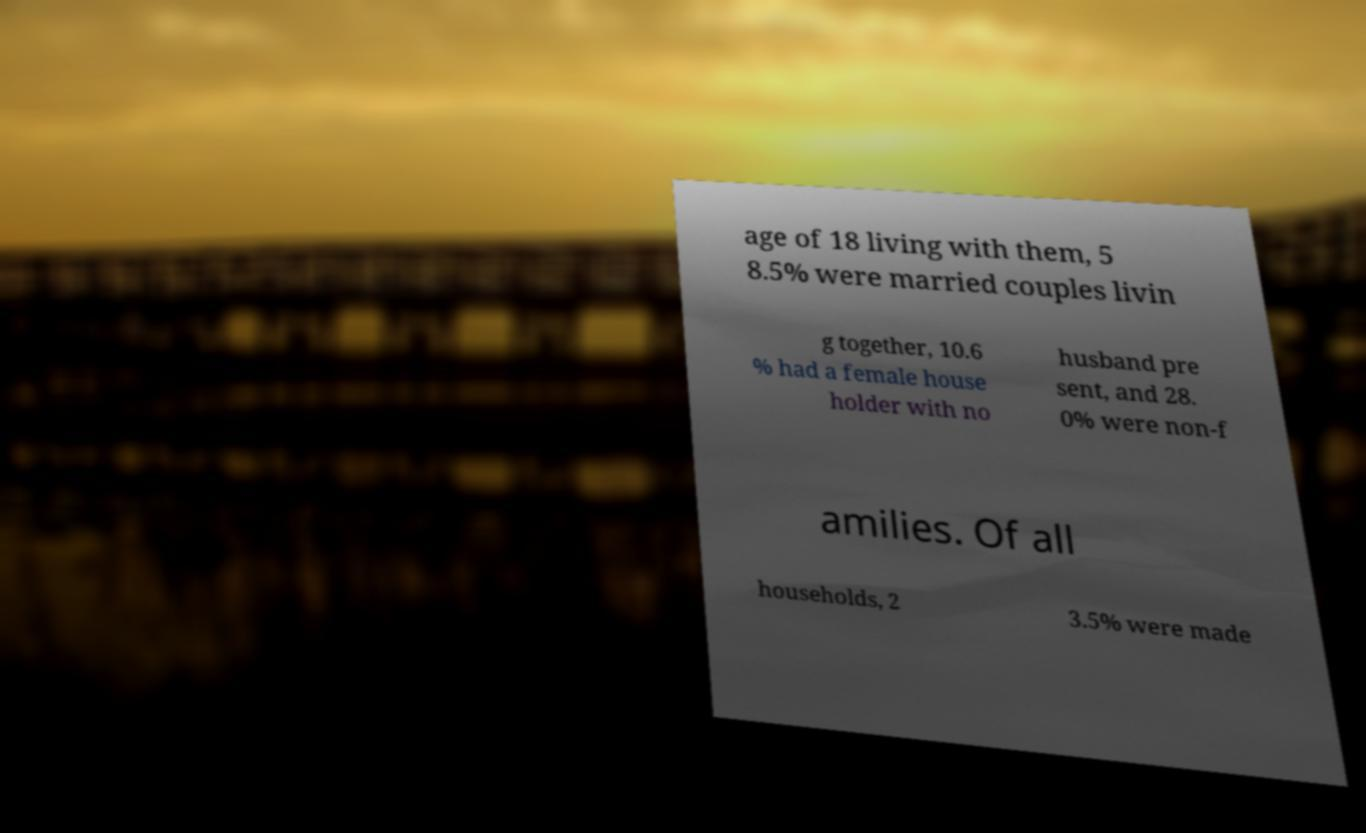I need the written content from this picture converted into text. Can you do that? age of 18 living with them, 5 8.5% were married couples livin g together, 10.6 % had a female house holder with no husband pre sent, and 28. 0% were non-f amilies. Of all households, 2 3.5% were made 